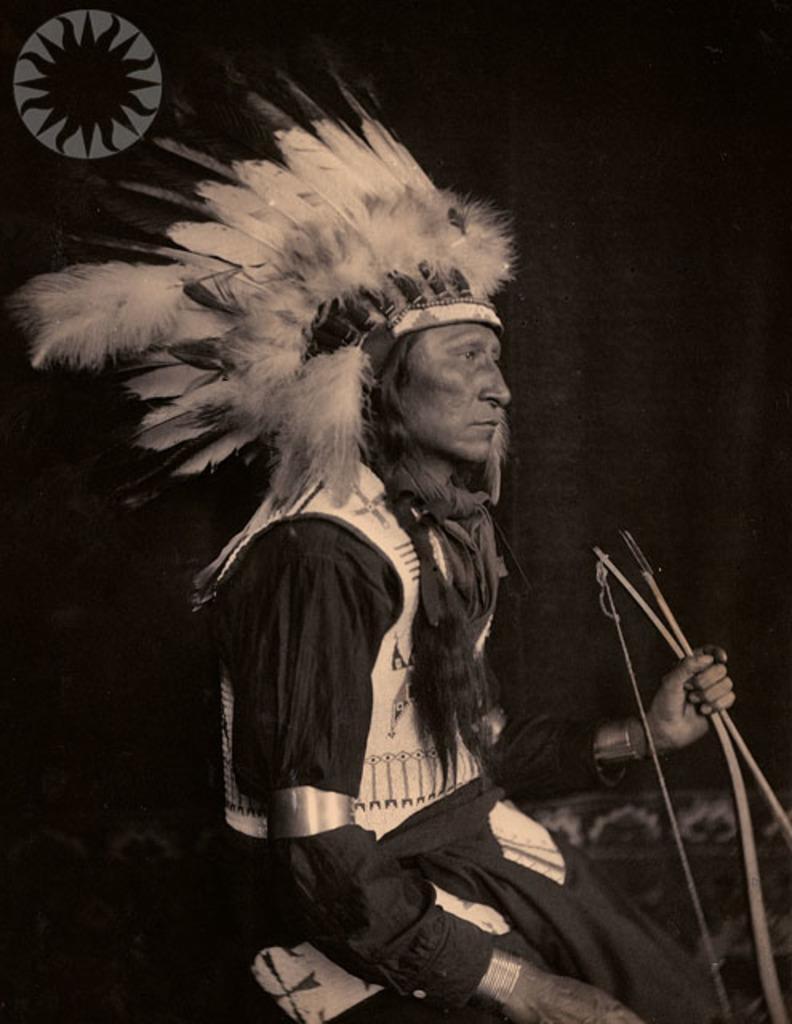Please provide a concise description of this image. As we can see in the image there is a man wearing black color dress and holding a bow. There are feathers and the background is dark. 